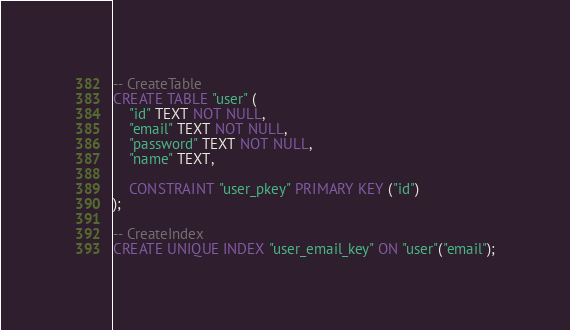<code> <loc_0><loc_0><loc_500><loc_500><_SQL_>-- CreateTable
CREATE TABLE "user" (
    "id" TEXT NOT NULL,
    "email" TEXT NOT NULL,
    "password" TEXT NOT NULL,
    "name" TEXT,

    CONSTRAINT "user_pkey" PRIMARY KEY ("id")
);

-- CreateIndex
CREATE UNIQUE INDEX "user_email_key" ON "user"("email");
</code> 